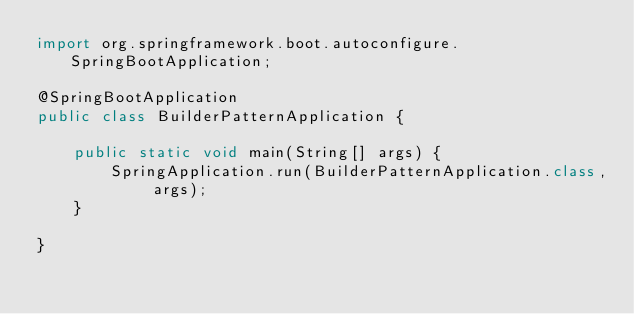<code> <loc_0><loc_0><loc_500><loc_500><_Java_>import org.springframework.boot.autoconfigure.SpringBootApplication;

@SpringBootApplication
public class BuilderPatternApplication {

    public static void main(String[] args) {
        SpringApplication.run(BuilderPatternApplication.class, args);
    }

}
</code> 